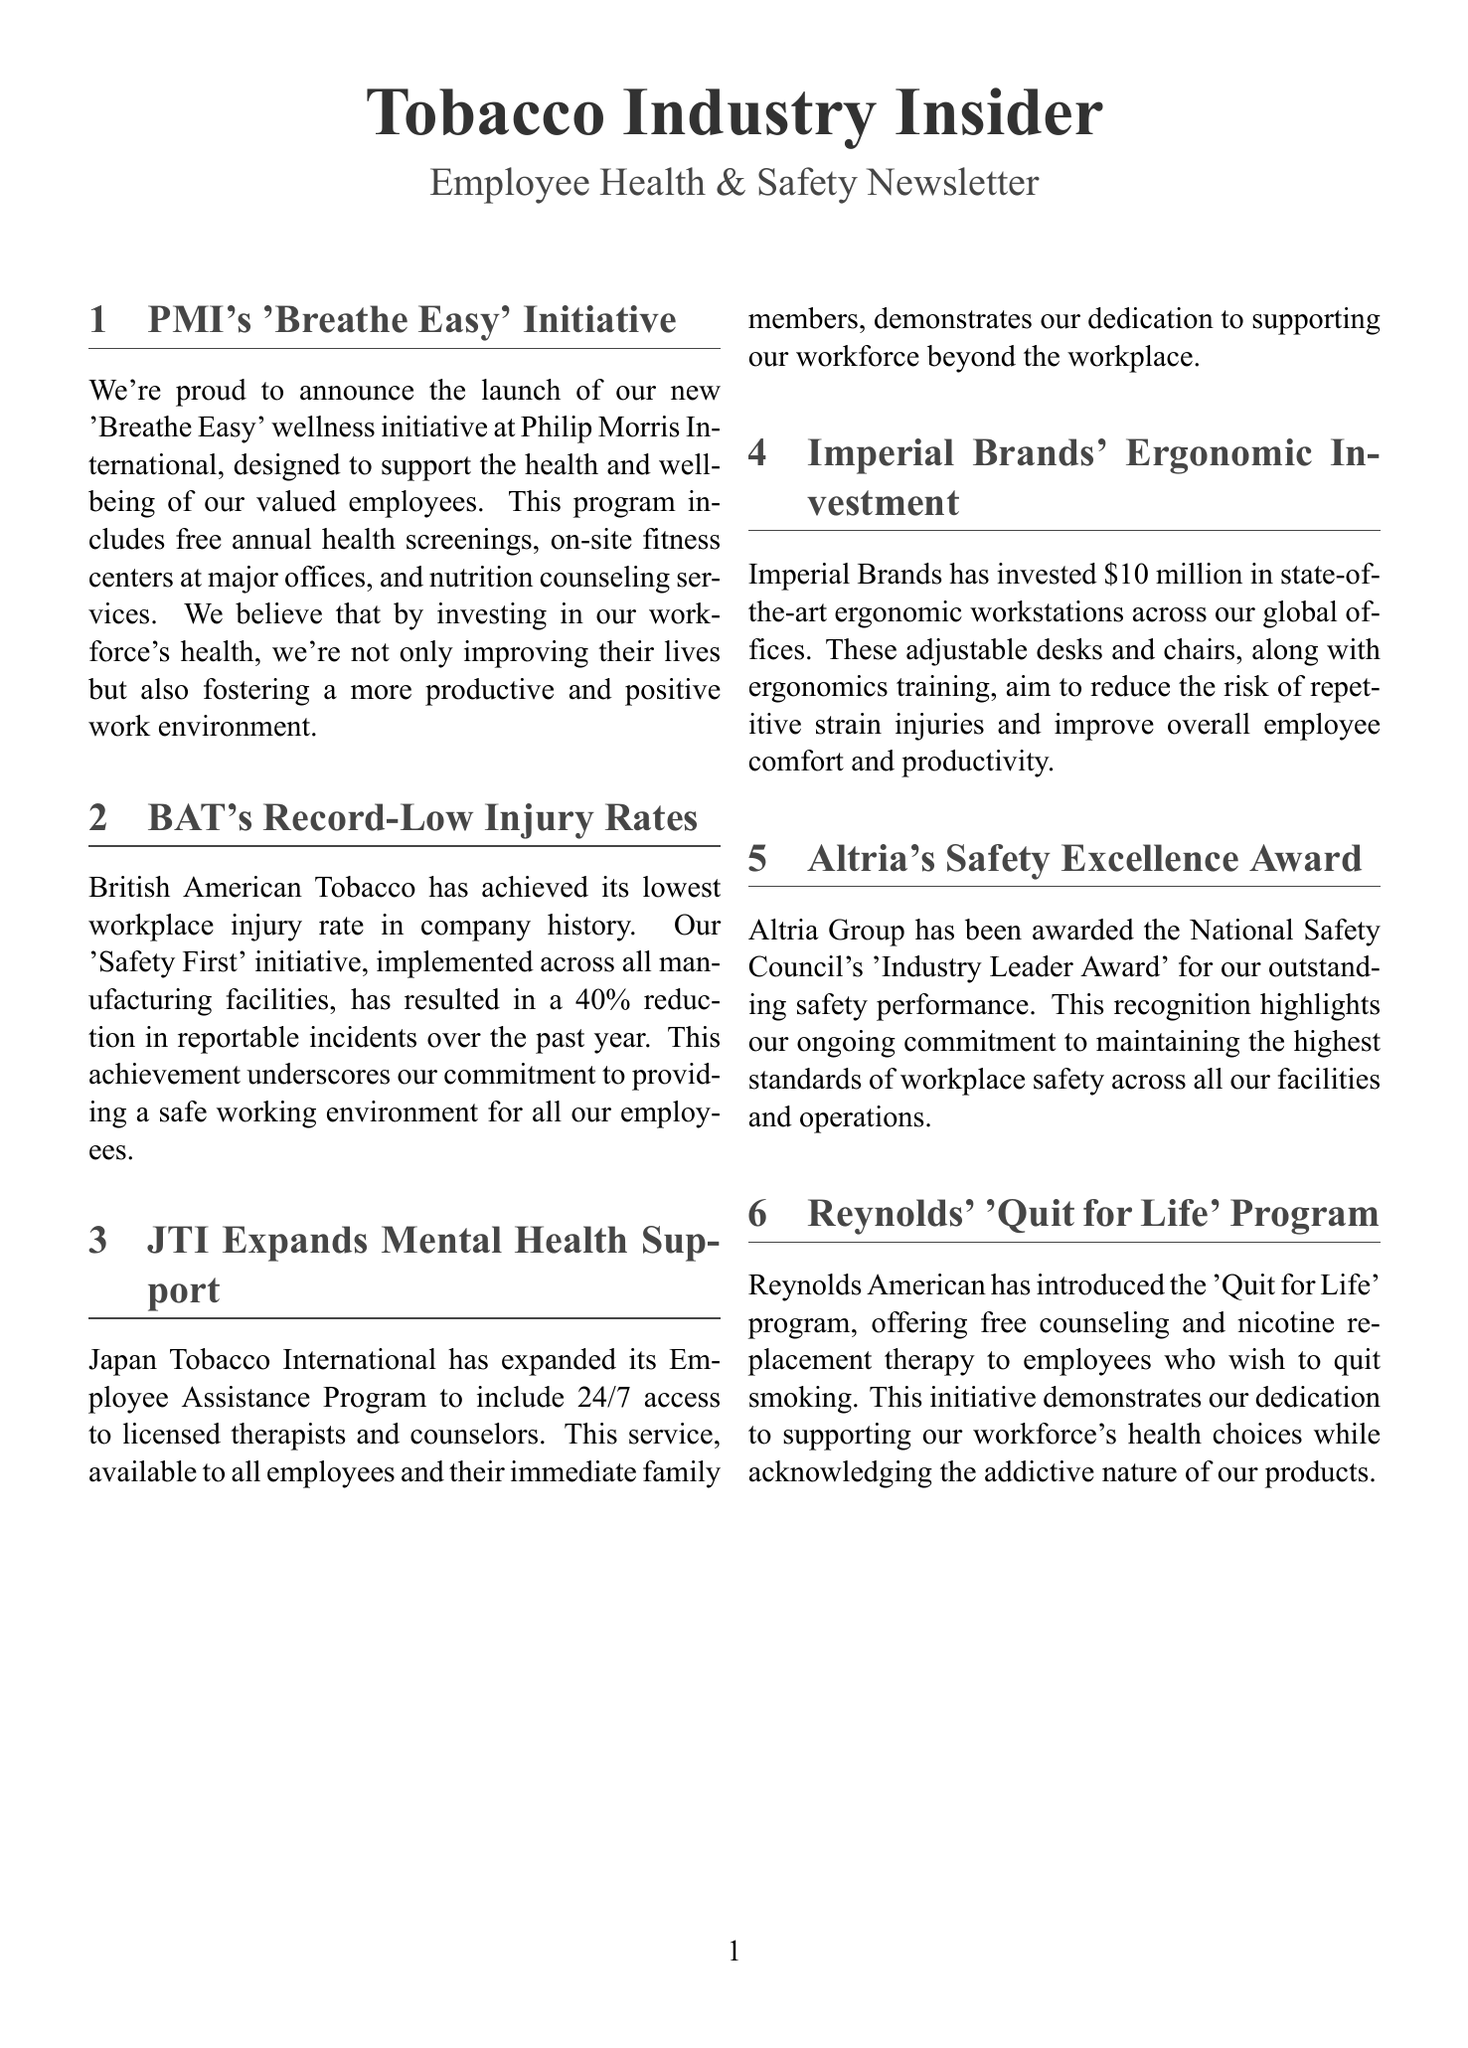What is the name of PMI's wellness initiative? The document mentions the 'Breathe Easy' wellness initiative launched by Philip Morris International.
Answer: 'Breathe Easy' What percentage reduction in reportable incidents did BAT achieve? The document states that BAT's 'Safety First' initiative has resulted in a 40% reduction in reportable incidents over the past year.
Answer: 40% How much has Imperial Brands invested in ergonomic workstations? According to the document, Imperial Brands has invested $10 million in ergonomic workstations across its global offices.
Answer: $10 million What type of mental health services has JTI expanded? JTI has expanded its Employee Assistance Program to include 24/7 access to licensed therapists and counselors.
Answer: 24/7 access to licensed therapists Which award did Altria Group receive? The document indicates that Altria Group received the National Safety Council's 'Industry Leader Award' for outstanding safety performance.
Answer: 'Industry Leader Award' What program has Reynolds American launched for smoking cessation? The document states that Reynolds American has introduced the 'Quit for Life' program to help employees quit smoking.
Answer: 'Quit for Life' program 